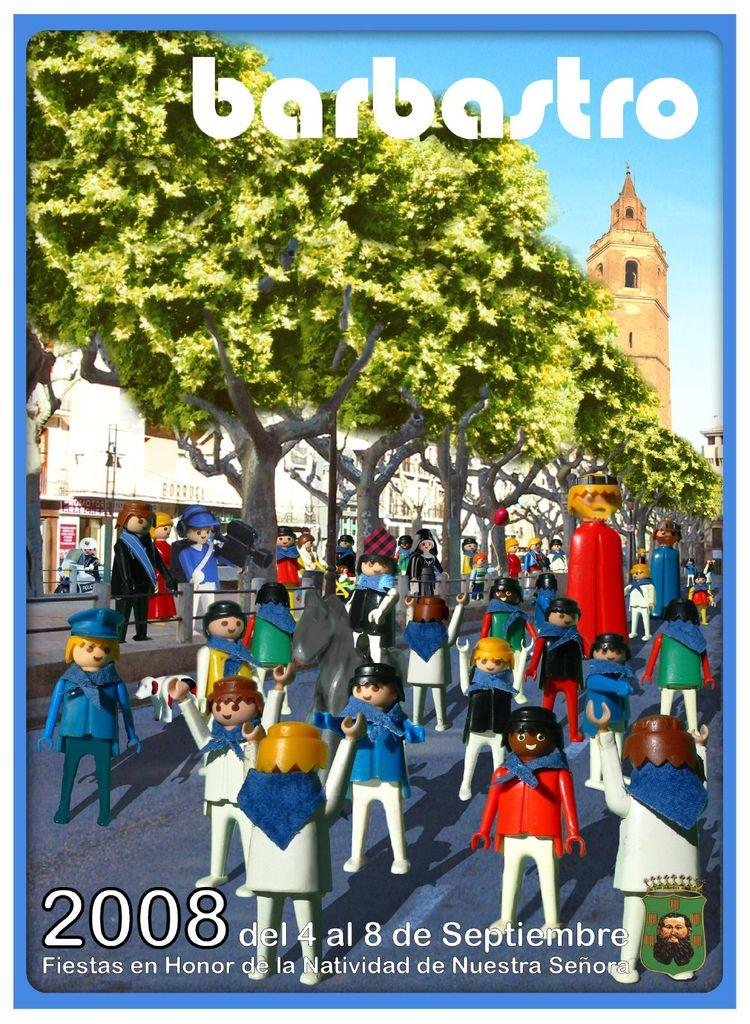<image>
Give a short and clear explanation of the subsequent image. A selection of lego characters on the cover of Barbastro in 2008. 